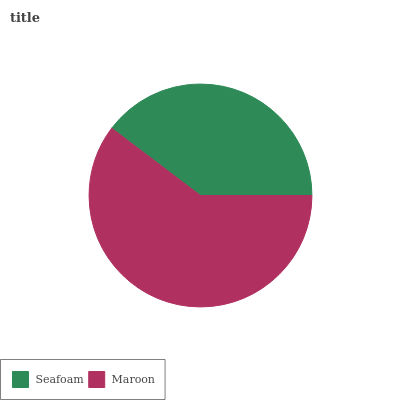Is Seafoam the minimum?
Answer yes or no. Yes. Is Maroon the maximum?
Answer yes or no. Yes. Is Maroon the minimum?
Answer yes or no. No. Is Maroon greater than Seafoam?
Answer yes or no. Yes. Is Seafoam less than Maroon?
Answer yes or no. Yes. Is Seafoam greater than Maroon?
Answer yes or no. No. Is Maroon less than Seafoam?
Answer yes or no. No. Is Maroon the high median?
Answer yes or no. Yes. Is Seafoam the low median?
Answer yes or no. Yes. Is Seafoam the high median?
Answer yes or no. No. Is Maroon the low median?
Answer yes or no. No. 